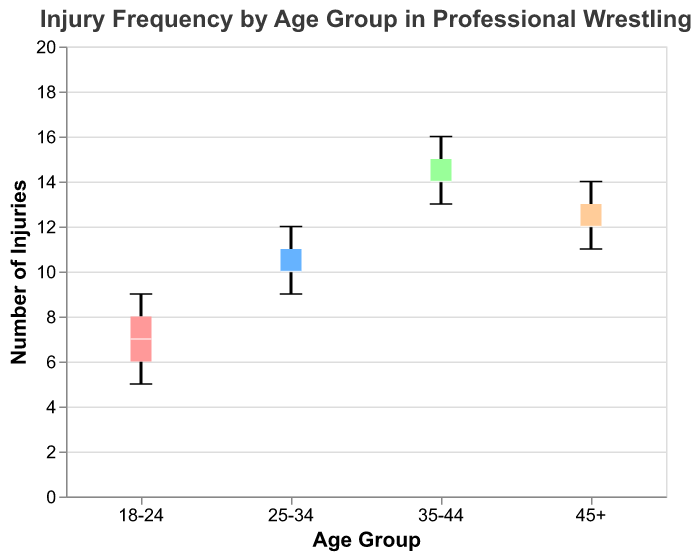What's the title of the figure? The title is displayed at the top of the box plot. It reads "Injury Frequency by Age Group in Professional Wrestling".
Answer: Injury Frequency by Age Group in Professional Wrestling What is the range of injuries for the 18-24 age group? The box plot displays the minimum and maximum values for each age group. For the 18-24 age group, the minimum value is 5 and the maximum value is 9.
Answer: 5 to 9 Which age group has the highest median number of injuries? The median is represented by the line inside each box. For the age groups 18-24, 25-34, 35-44, and 45+, the median values are 7, 10, 14, and 12 respectively. The highest median is in the 35-44 age group.
Answer: 35-44 What is the interquartile range (IQR) for the 35-44 age group? The IQR is the difference between the third quartile (Q3) and the first quartile (Q1), represented by the top and bottom of the box. For the 35-44 age group, if Q3 is 15 and Q1 is 14, the IQR is 15 - 14.
Answer: 1 Are there any outliers in the dataset? An outlier in a box plot would be indicated by dots outside the whiskers. The box plot does not show any dots outside the whiskers, suggesting there are no outliers.
Answer: No Which age group shows the widest variability in the number of injuries? The variability is shown by the length of the whiskers. The age group 35-44 has the widest range from its minimum (13) to its maximum (16), indicating the highest variability.
Answer: 35-44 Which age group has the lowest maximum number of injuries? The top of the whisker shows the maximum number of injuries for each age group. The 18-24 age group has the lowest maximum value of 9 injuries compared to the other groups.
Answer: 18-24 What is the median value of injuries for the 45+ age group? The median is represented by the line inside the box. For the 45+ age group, the line is at 12 injuries.
Answer: 12 What's the total count of injuries recorded for the 25-34 age group? The box plot shows individual data points, and there are a total of five data points for the 25-34 age group. The number of injuries can be summed as 10 + 12 + 11 + 9 + 10. The total is 52.
Answer: 52 